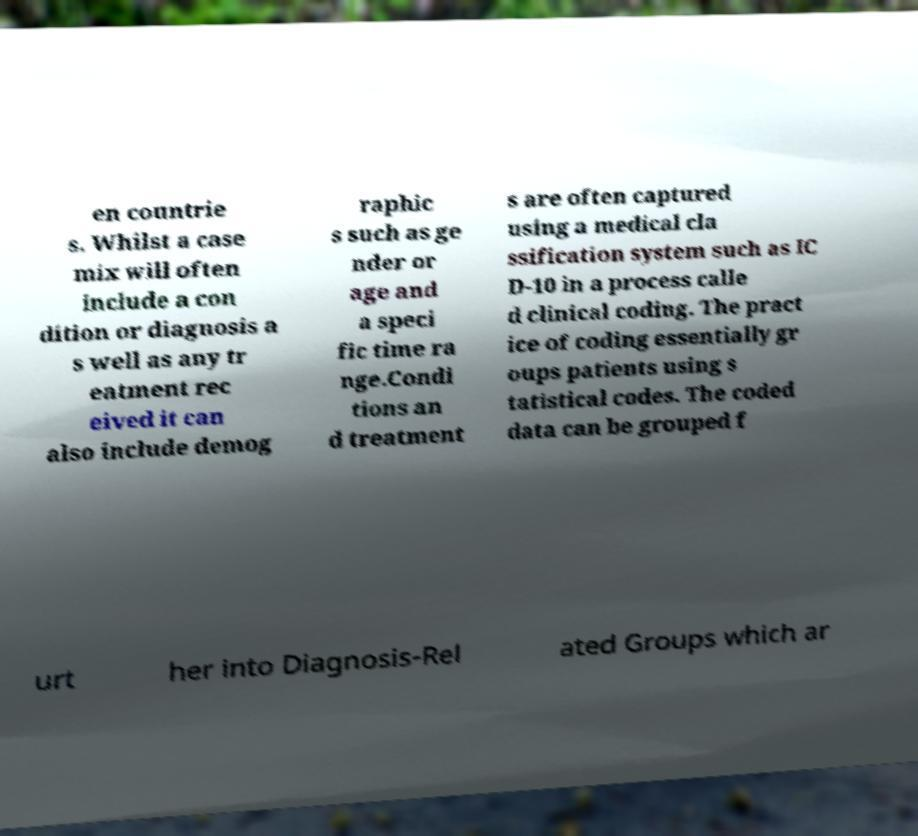What messages or text are displayed in this image? I need them in a readable, typed format. en countrie s. Whilst a case mix will often include a con dition or diagnosis a s well as any tr eatment rec eived it can also include demog raphic s such as ge nder or age and a speci fic time ra nge.Condi tions an d treatment s are often captured using a medical cla ssification system such as IC D-10 in a process calle d clinical coding. The pract ice of coding essentially gr oups patients using s tatistical codes. The coded data can be grouped f urt her into Diagnosis-Rel ated Groups which ar 